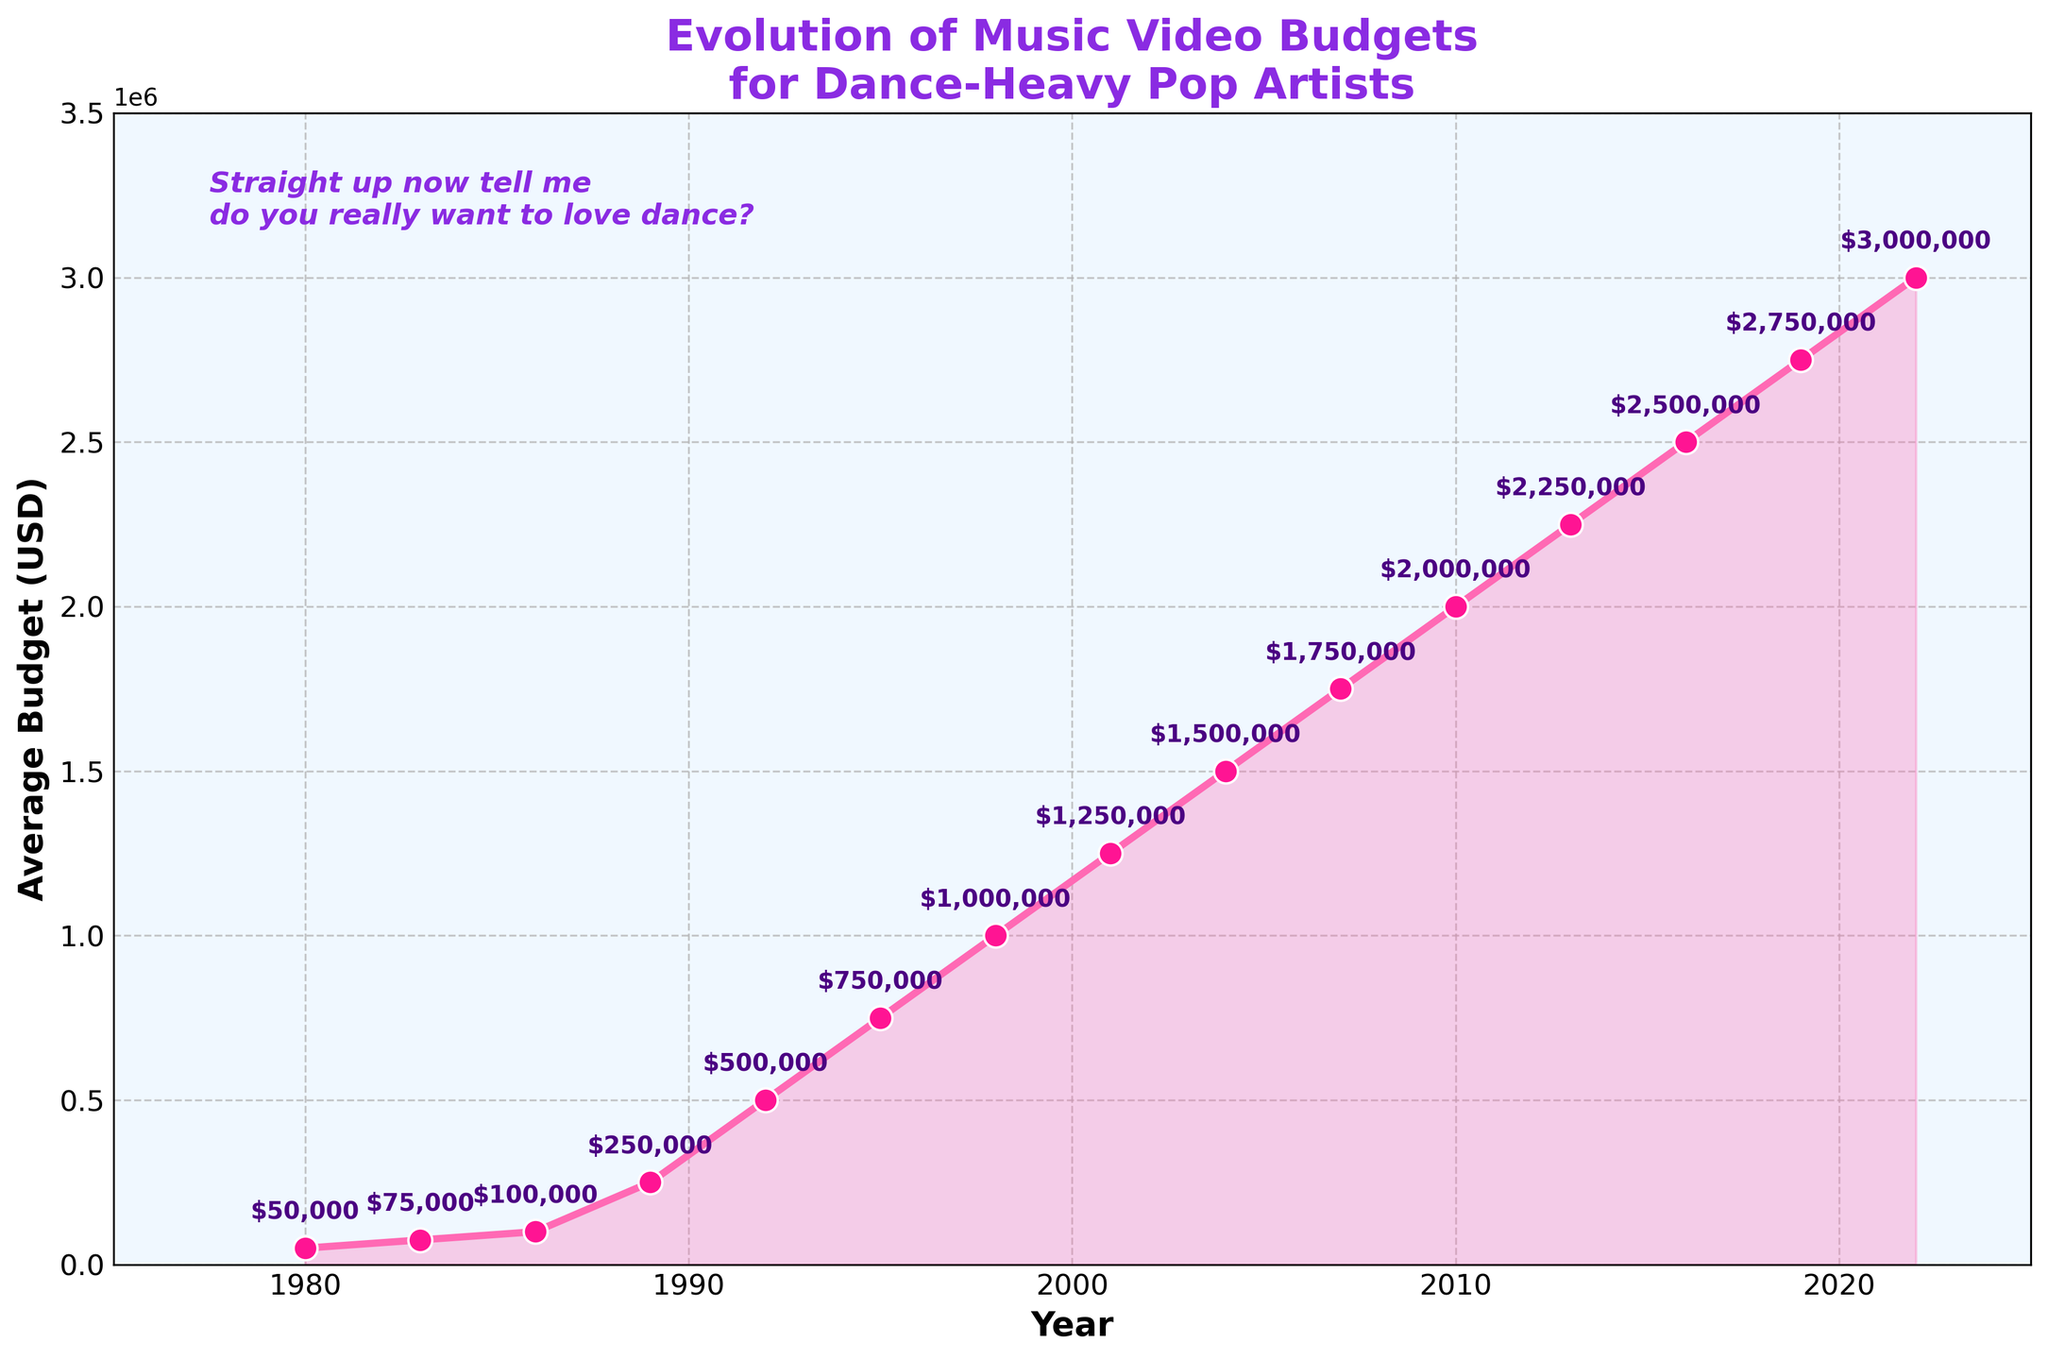What is the average budget for music videos in 2022? The figure shows the average budget for each year. In 2022, it is $3,000,000.
Answer: $3,000,000 How much did the average budget increase from 1980 to 1989? The budget in 1980 was $50,000 and in 1989 it was $250,000. The increase is $250,000 - $50,000 = $200,000.
Answer: $200,000 Compare the average budget in 1998 with that in 2010. In 1998, the budget was $1,000,000, and in 2010, it was $2,000,000. Hence, the budget in 1998 is half of that in 2010.
Answer: 1998 budget is half of 2010 What is the overall trend of music video budgets from 1980 to 2022? The figure shows a continuous increase in music video budgets from 1980 ($50,000) to 2022 ($3,000,000).
Answer: Continuous increase What is the difference between the budgets in 2001 and 2007? The budget in 2001 was $1,250,000 and in 2007 it was $1,750,000. The difference is $1,750,000 - $1,250,000 = $500,000.
Answer: $500,000 How does the budget in 2016 compare to that in 2013? The budget in 2013 was $2,250,000 and in 2016 it was $2,500,000. The budget increased by $250,000.
Answer: Increased by $250,000 When did the average budget first exceed $1,000,000? By examining the plot, the first year the budget exceeds $1,000,000 is 1998.
Answer: 1998 By what percentage did the average budget increase from 1986 to 1995? The budget in 1986 was $100,000 and in 1995 it was $750,000. The percentage increase is ((750,000 - 100,000) / 100,000) * 100 = 650%.
Answer: 650% What year saw the largest single increase in average budget? The figure shows the largest single increase between 1989 ($250,000) and 1992 ($500,000), with an increase of $250,000.
Answer: 1989 to 1992 Between which consecutive years did the budget increase by exactly $250,000? The plots show the budget increased by exactly $250,000 between 2013 ($2,250,000) and 2016 ($2,500,000).
Answer: 2013 to 2016 